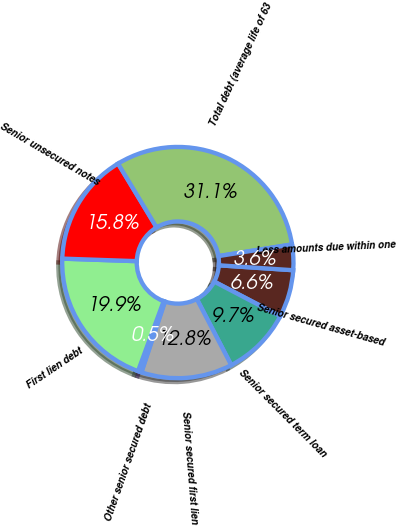<chart> <loc_0><loc_0><loc_500><loc_500><pie_chart><fcel>Senior secured asset-based<fcel>Senior secured term loan<fcel>Senior secured first lien<fcel>Other senior secured debt<fcel>First lien debt<fcel>Senior unsecured notes<fcel>Total debt (average life of 63<fcel>Less amounts due within one<nl><fcel>6.62%<fcel>9.68%<fcel>12.75%<fcel>0.49%<fcel>19.95%<fcel>15.81%<fcel>31.14%<fcel>3.56%<nl></chart> 